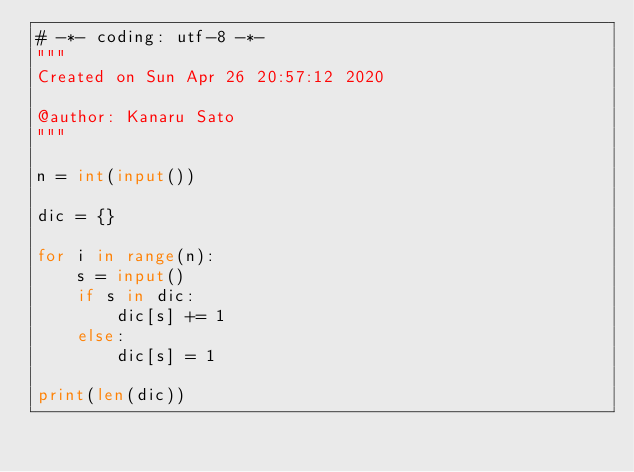Convert code to text. <code><loc_0><loc_0><loc_500><loc_500><_Python_># -*- coding: utf-8 -*-
"""
Created on Sun Apr 26 20:57:12 2020

@author: Kanaru Sato
"""

n = int(input())

dic = {}

for i in range(n):
    s = input()
    if s in dic:
        dic[s] += 1
    else:
        dic[s] = 1

print(len(dic))</code> 